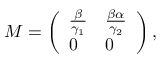<formula> <loc_0><loc_0><loc_500><loc_500>M = \left ( \begin{array} { l l } { \frac { \beta } { \gamma _ { 1 } } } & { \frac { \beta \alpha } { \gamma _ { 2 } } } \\ { 0 } & { 0 } \end{array} \right ) ,</formula> 